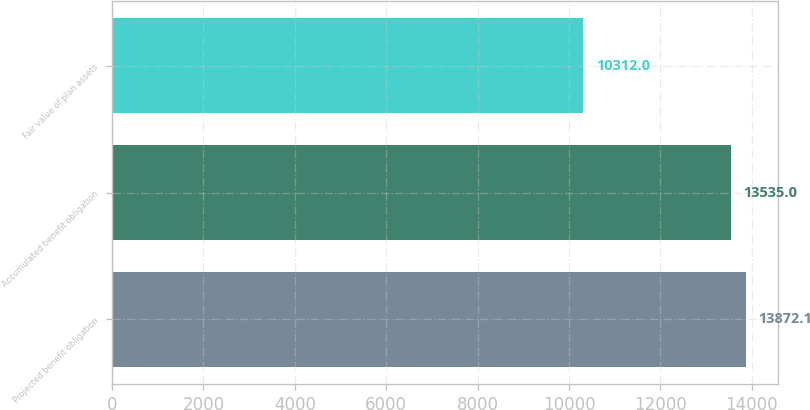<chart> <loc_0><loc_0><loc_500><loc_500><bar_chart><fcel>Projected benefit obligation<fcel>Accumulated benefit obligation<fcel>Fair value of plan assets<nl><fcel>13872.1<fcel>13535<fcel>10312<nl></chart> 